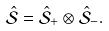<formula> <loc_0><loc_0><loc_500><loc_500>\hat { \mathcal { S } } = \hat { \mathcal { S } } _ { + } \otimes \hat { \mathcal { S } } _ { - } .</formula> 